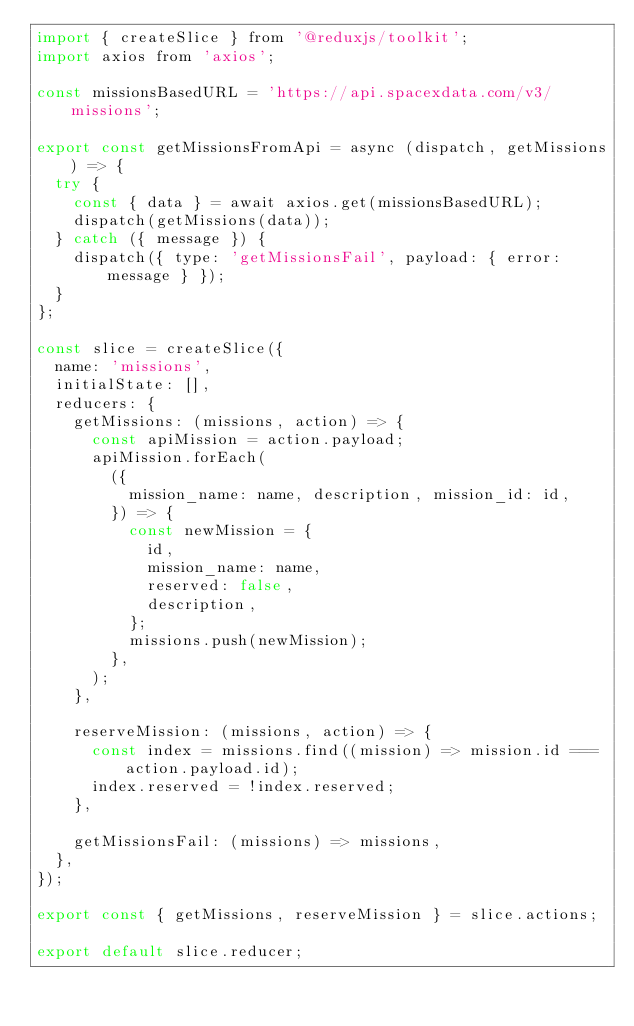<code> <loc_0><loc_0><loc_500><loc_500><_JavaScript_>import { createSlice } from '@reduxjs/toolkit';
import axios from 'axios';

const missionsBasedURL = 'https://api.spacexdata.com/v3/missions';

export const getMissionsFromApi = async (dispatch, getMissions) => {
  try {
    const { data } = await axios.get(missionsBasedURL);
    dispatch(getMissions(data));
  } catch ({ message }) {
    dispatch({ type: 'getMissionsFail', payload: { error: message } });
  }
};

const slice = createSlice({
  name: 'missions',
  initialState: [],
  reducers: {
    getMissions: (missions, action) => {
      const apiMission = action.payload;
      apiMission.forEach(
        ({
          mission_name: name, description, mission_id: id,
        }) => {
          const newMission = {
            id,
            mission_name: name,
            reserved: false,
            description,
          };
          missions.push(newMission);
        },
      );
    },

    reserveMission: (missions, action) => {
      const index = missions.find((mission) => mission.id === action.payload.id);
      index.reserved = !index.reserved;
    },

    getMissionsFail: (missions) => missions,
  },
});

export const { getMissions, reserveMission } = slice.actions;

export default slice.reducer;
</code> 